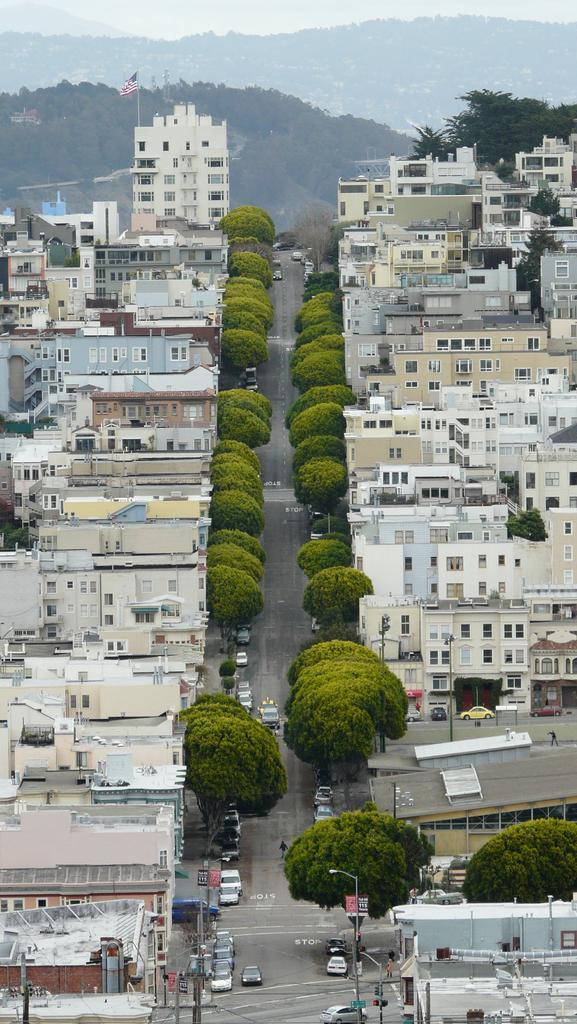What type of view is shown in the image? The image is an aerial view. What structures can be seen in the image? There are buildings in the image. What natural elements are present in the image? There are trees in the image. What man-made objects can be seen on the ground in the image? There are cars on the road in the image. What geographical feature is visible in the background of the image? There are mountains in the background of the image. Is there any symbol or emblem visible on any of the buildings? Yes, there is a flag on one building in the image. What time does the clock on the building show in the image? There is no clock visible on any of the buildings in the image. Can you describe the trousers worn by the trees in the image? Trees do not wear trousers, as they are natural elements and not human beings. 